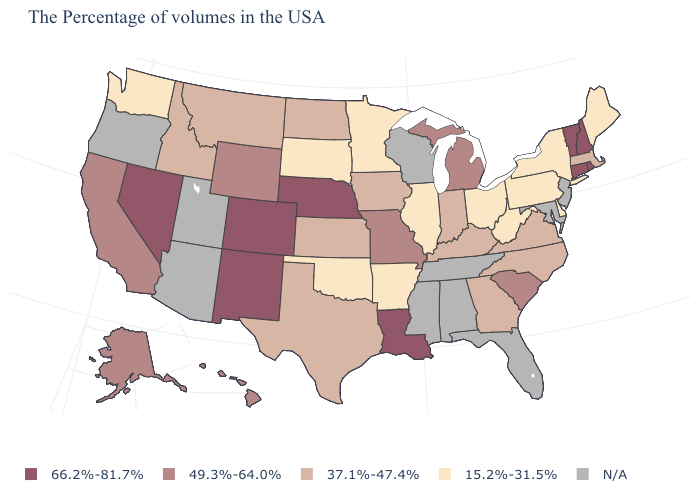Does the map have missing data?
Quick response, please. Yes. Is the legend a continuous bar?
Short answer required. No. Does Rhode Island have the highest value in the USA?
Quick response, please. Yes. What is the value of Connecticut?
Be succinct. 66.2%-81.7%. Which states have the highest value in the USA?
Answer briefly. Rhode Island, New Hampshire, Vermont, Connecticut, Louisiana, Nebraska, Colorado, New Mexico, Nevada. Does Michigan have the lowest value in the USA?
Concise answer only. No. Which states hav the highest value in the South?
Short answer required. Louisiana. What is the value of Louisiana?
Write a very short answer. 66.2%-81.7%. What is the value of Alabama?
Be succinct. N/A. What is the highest value in the West ?
Be succinct. 66.2%-81.7%. Which states have the lowest value in the MidWest?
Be succinct. Ohio, Illinois, Minnesota, South Dakota. Which states hav the highest value in the South?
Keep it brief. Louisiana. Among the states that border Missouri , does Nebraska have the highest value?
Be succinct. Yes. What is the highest value in the USA?
Be succinct. 66.2%-81.7%. Name the states that have a value in the range 66.2%-81.7%?
Answer briefly. Rhode Island, New Hampshire, Vermont, Connecticut, Louisiana, Nebraska, Colorado, New Mexico, Nevada. 